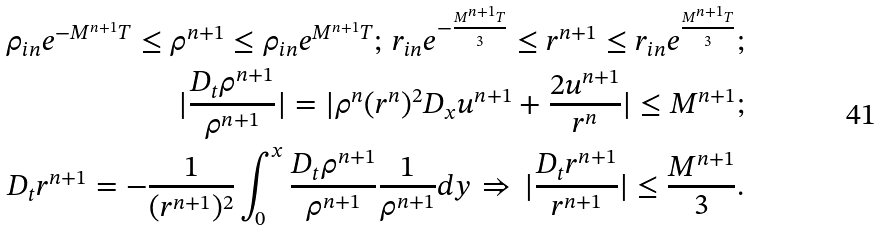Convert formula to latex. <formula><loc_0><loc_0><loc_500><loc_500>\rho _ { i n } e ^ { - M ^ { n + 1 } T } \leq \rho ^ { n + 1 } \leq \rho _ { i n } e ^ { M ^ { n + 1 } T } ; \, r _ { i n } e ^ { - \frac { M ^ { n + 1 } T } { 3 } } \leq r ^ { n + 1 } \leq r _ { i n } e ^ { \frac { M ^ { n + 1 } T } { 3 } } ; \\ | \frac { D _ { t } \rho ^ { n + 1 } } { \rho ^ { n + 1 } } | = | \rho ^ { n } ( r ^ { n } ) ^ { 2 } D _ { x } u ^ { n + 1 } + \frac { 2 u ^ { n + 1 } } { r ^ { n } } | \leq M ^ { n + 1 } ; \\ D _ { t } r ^ { n + 1 } = - \frac { 1 } { ( r ^ { n + 1 } ) ^ { 2 } } \int _ { 0 } ^ { x } \frac { D _ { t } \rho ^ { n + 1 } } { \rho ^ { n + 1 } } \frac { 1 } { \rho ^ { n + 1 } } d y \, \Rightarrow \, | \frac { D _ { t } r ^ { n + 1 } } { r ^ { n + 1 } } | \leq \frac { M ^ { n + 1 } } { 3 } .</formula> 